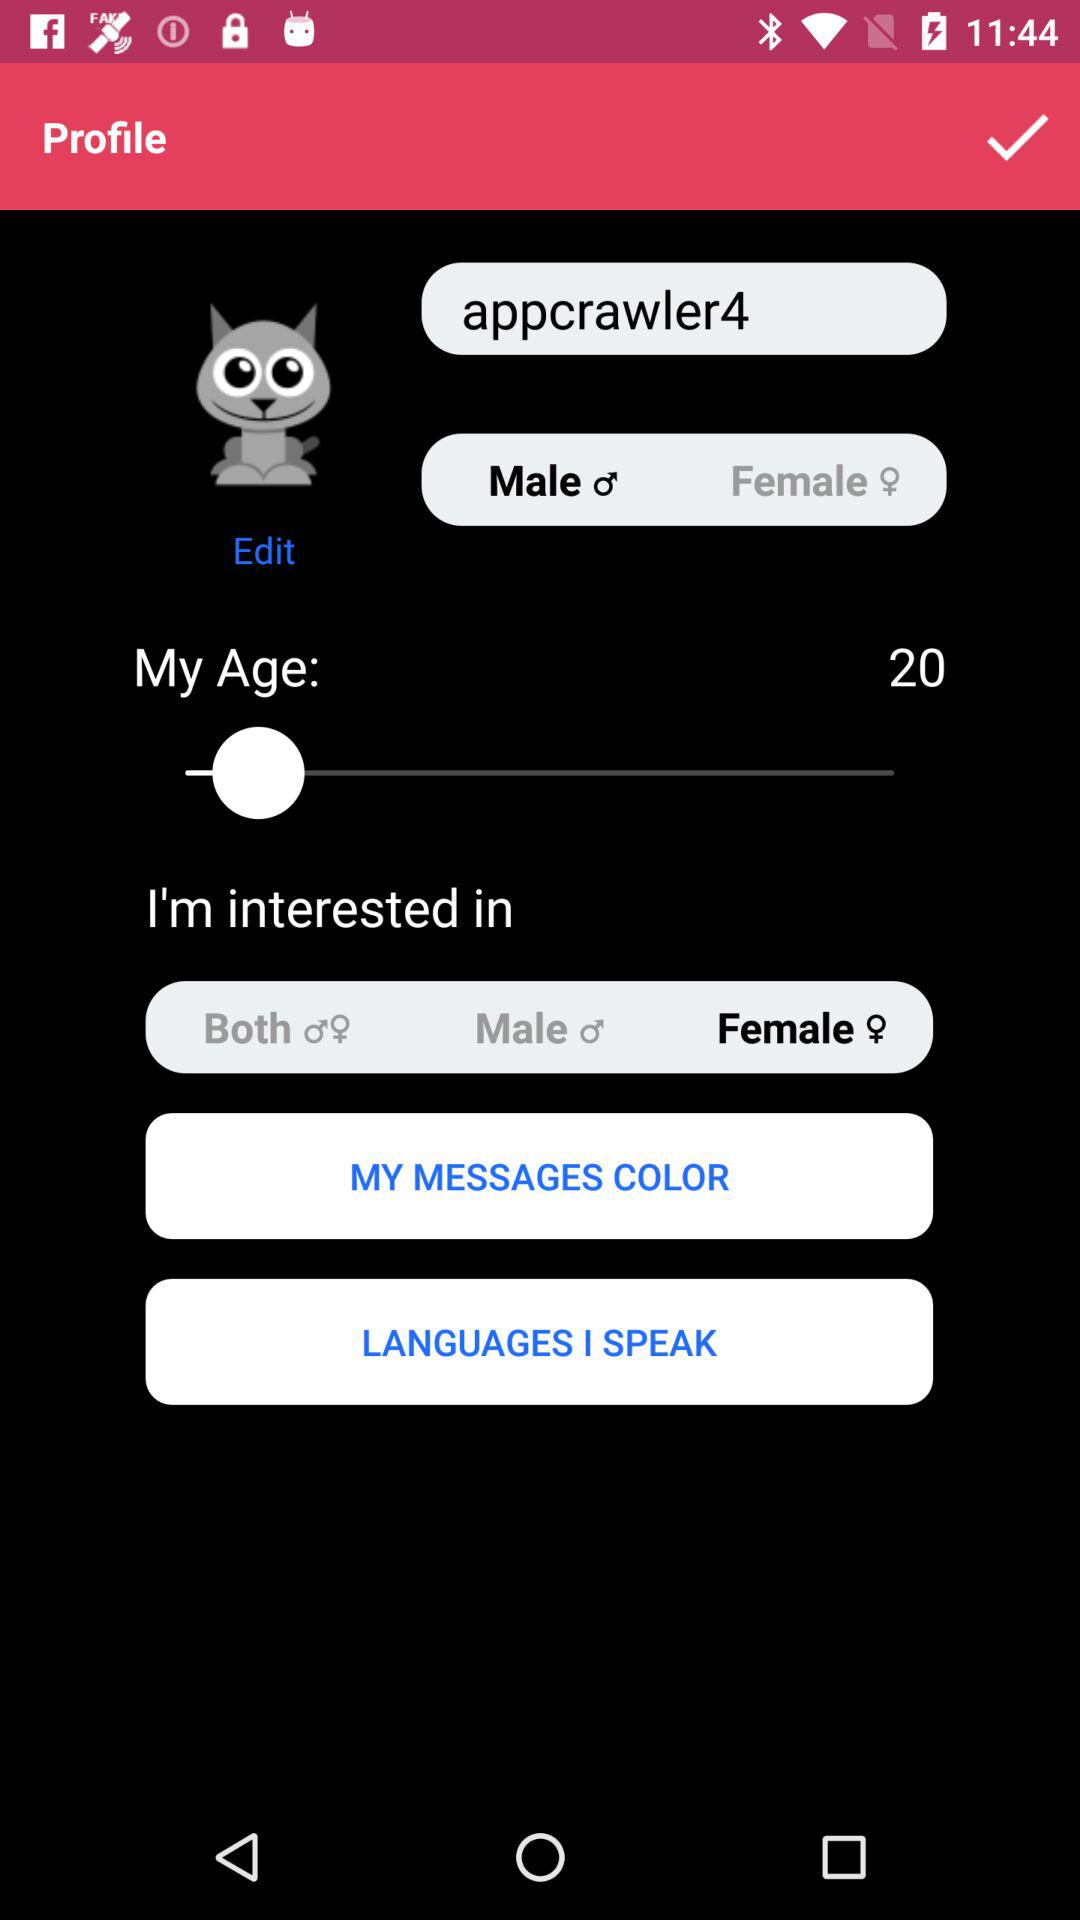What is the age of the person? The age of the person is 20 years old. 